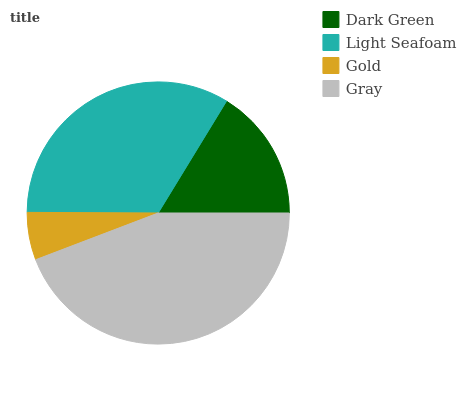Is Gold the minimum?
Answer yes or no. Yes. Is Gray the maximum?
Answer yes or no. Yes. Is Light Seafoam the minimum?
Answer yes or no. No. Is Light Seafoam the maximum?
Answer yes or no. No. Is Light Seafoam greater than Dark Green?
Answer yes or no. Yes. Is Dark Green less than Light Seafoam?
Answer yes or no. Yes. Is Dark Green greater than Light Seafoam?
Answer yes or no. No. Is Light Seafoam less than Dark Green?
Answer yes or no. No. Is Light Seafoam the high median?
Answer yes or no. Yes. Is Dark Green the low median?
Answer yes or no. Yes. Is Gray the high median?
Answer yes or no. No. Is Gray the low median?
Answer yes or no. No. 